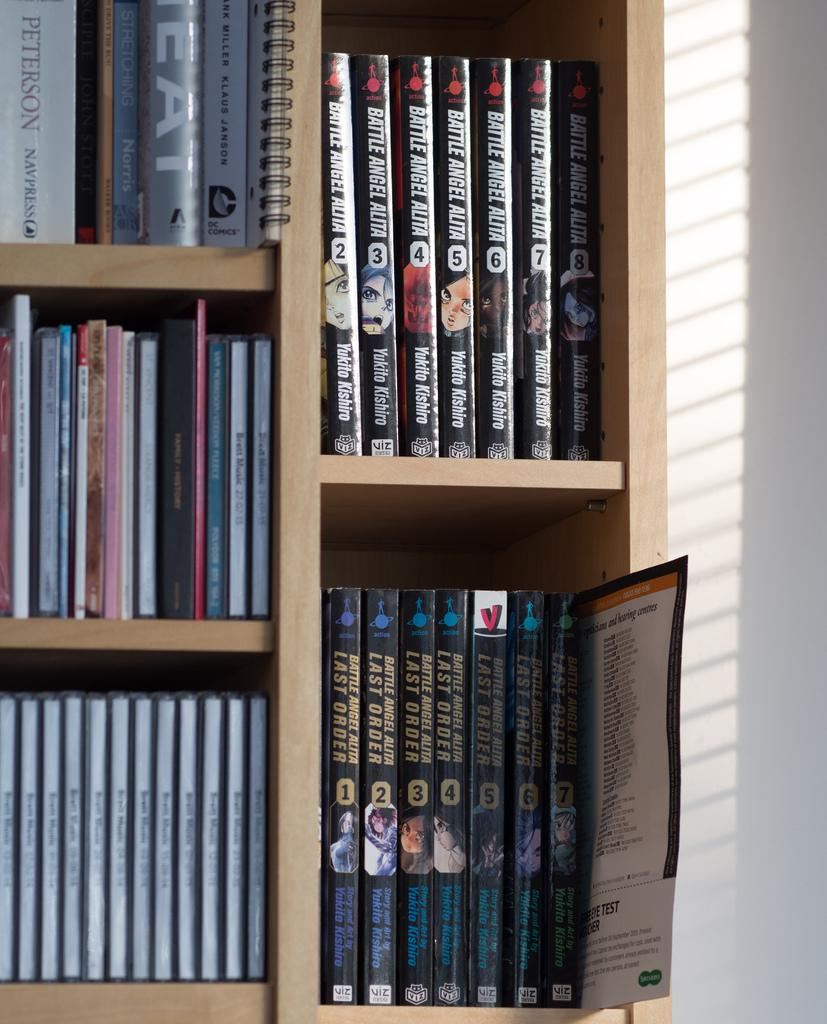<image>
Offer a succinct explanation of the picture presented. A number of books such as The Last Order 1-7 are on a bookshelf. 